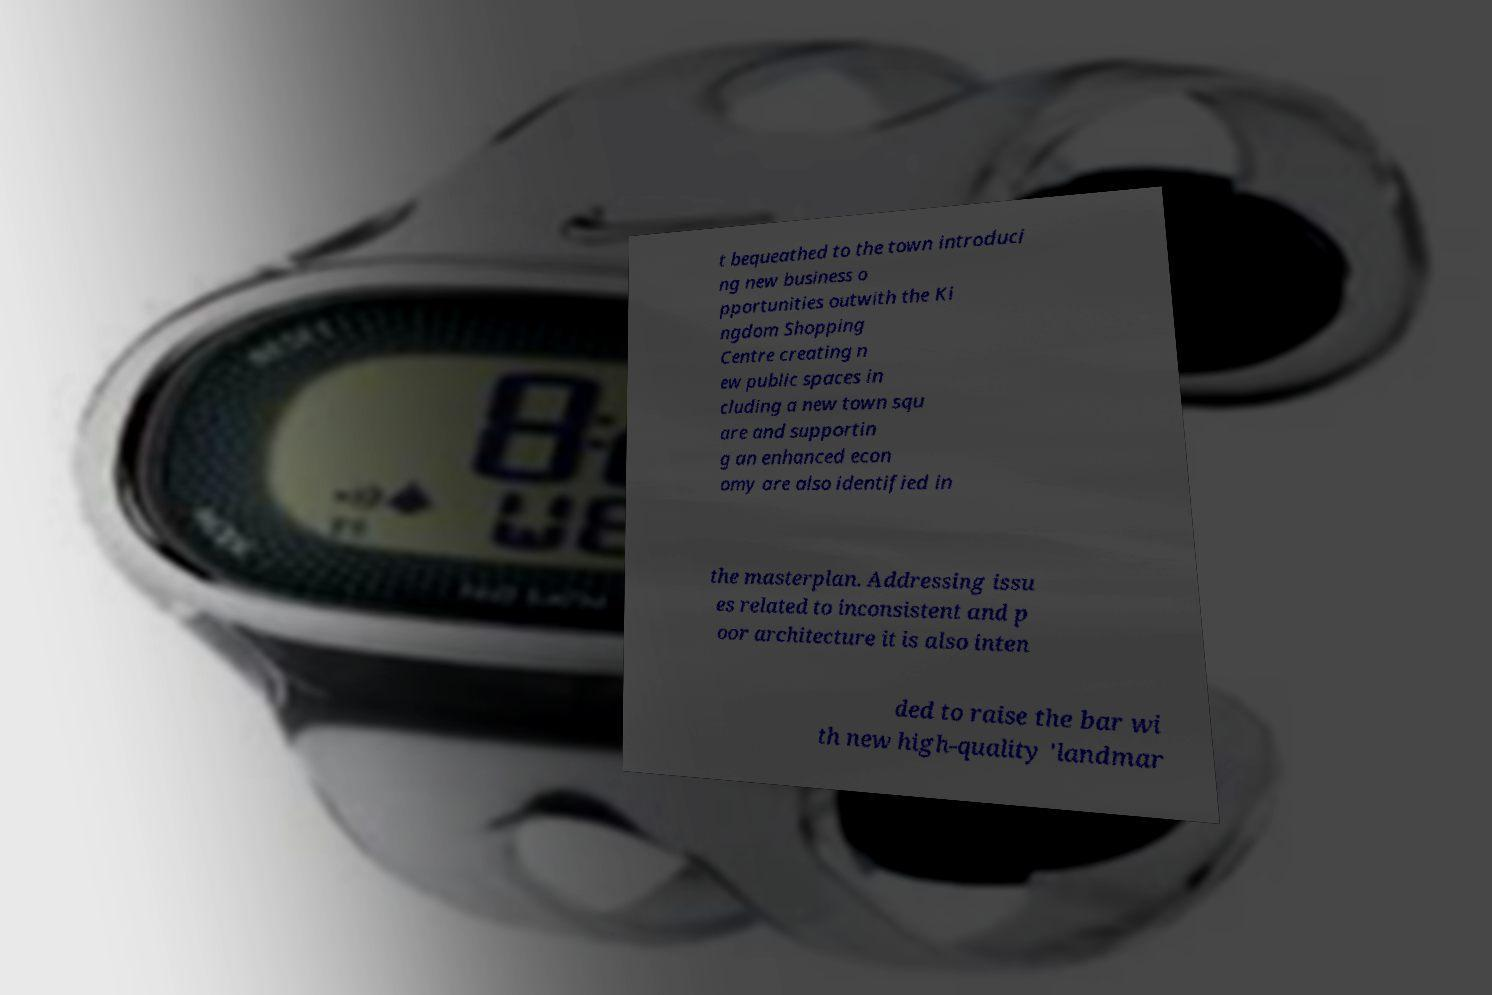What messages or text are displayed in this image? I need them in a readable, typed format. t bequeathed to the town introduci ng new business o pportunities outwith the Ki ngdom Shopping Centre creating n ew public spaces in cluding a new town squ are and supportin g an enhanced econ omy are also identified in the masterplan. Addressing issu es related to inconsistent and p oor architecture it is also inten ded to raise the bar wi th new high-quality 'landmar 